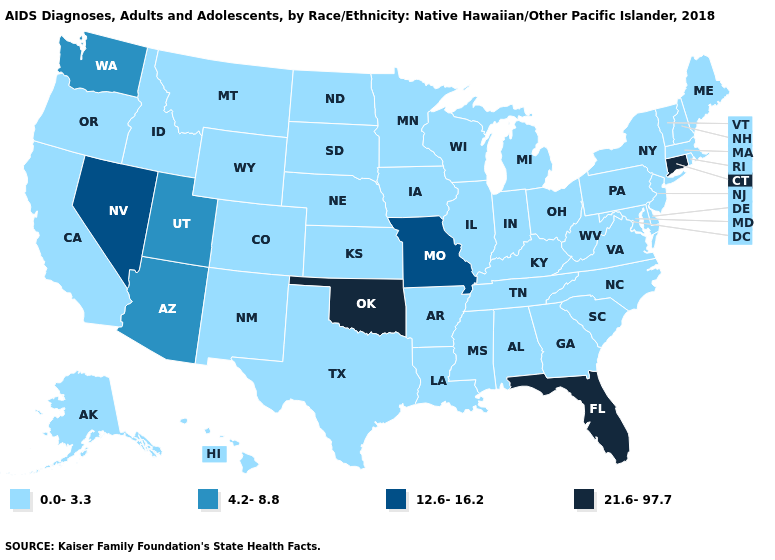Name the states that have a value in the range 21.6-97.7?
Answer briefly. Connecticut, Florida, Oklahoma. Name the states that have a value in the range 21.6-97.7?
Quick response, please. Connecticut, Florida, Oklahoma. What is the highest value in the USA?
Answer briefly. 21.6-97.7. Name the states that have a value in the range 12.6-16.2?
Keep it brief. Missouri, Nevada. Which states hav the highest value in the MidWest?
Be succinct. Missouri. Among the states that border Massachusetts , does New Hampshire have the lowest value?
Keep it brief. Yes. What is the value of Minnesota?
Concise answer only. 0.0-3.3. Among the states that border Wyoming , does Utah have the highest value?
Write a very short answer. Yes. Name the states that have a value in the range 0.0-3.3?
Write a very short answer. Alabama, Alaska, Arkansas, California, Colorado, Delaware, Georgia, Hawaii, Idaho, Illinois, Indiana, Iowa, Kansas, Kentucky, Louisiana, Maine, Maryland, Massachusetts, Michigan, Minnesota, Mississippi, Montana, Nebraska, New Hampshire, New Jersey, New Mexico, New York, North Carolina, North Dakota, Ohio, Oregon, Pennsylvania, Rhode Island, South Carolina, South Dakota, Tennessee, Texas, Vermont, Virginia, West Virginia, Wisconsin, Wyoming. What is the lowest value in the USA?
Keep it brief. 0.0-3.3. What is the lowest value in the USA?
Keep it brief. 0.0-3.3. Name the states that have a value in the range 12.6-16.2?
Concise answer only. Missouri, Nevada. What is the value of Idaho?
Write a very short answer. 0.0-3.3. What is the lowest value in states that border Texas?
Give a very brief answer. 0.0-3.3. 